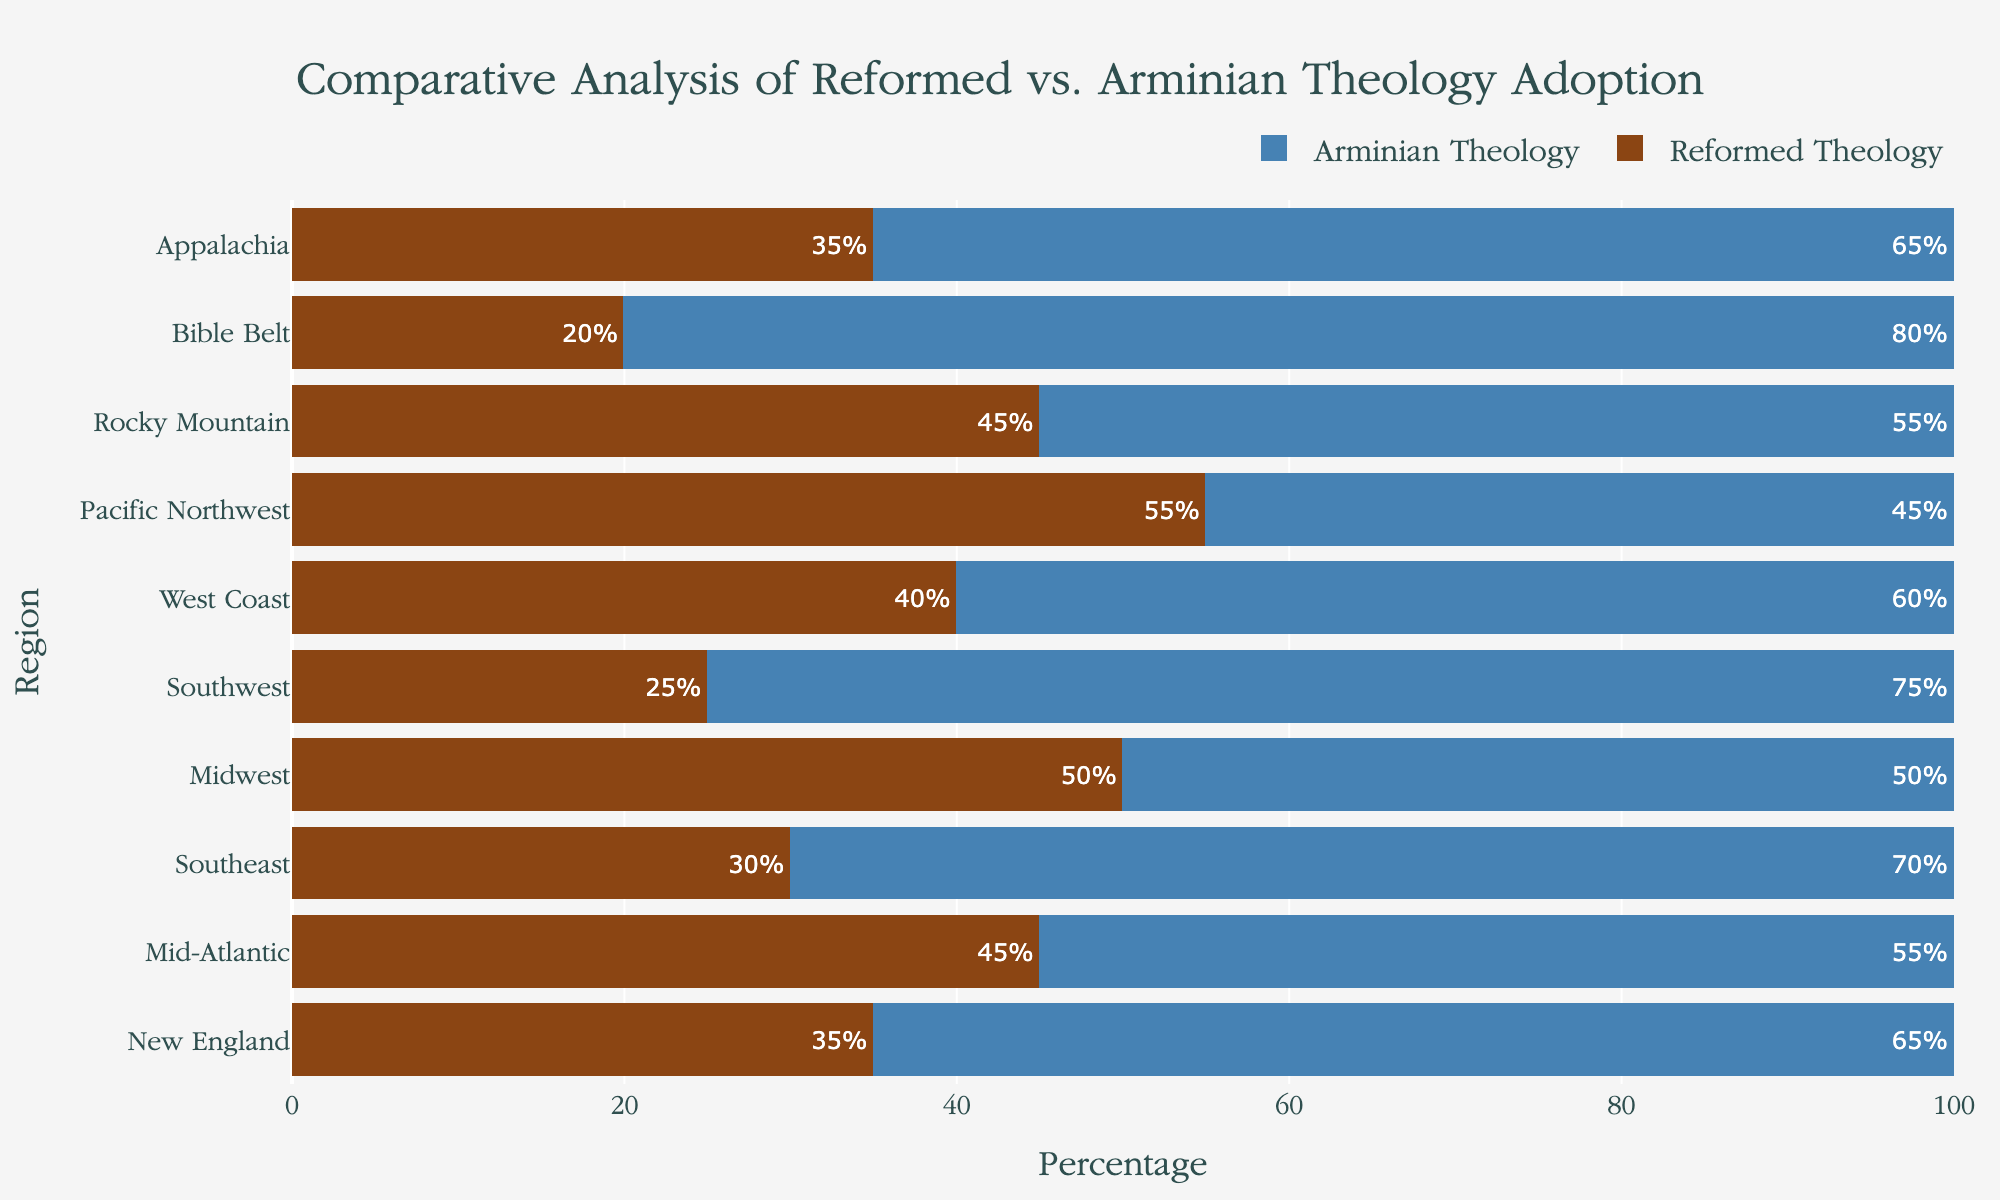How many regions have more than 50% adoption of Reformed Theology? To find this, identify which regions have a bar for Reformed Theology extending beyond the 50% mark on the x-axis. The regions with more than 50% adoption are the Midwest and the Pacific Northwest.
Answer: 2 Which region has the highest adoption rate of Arminian Theology? To determine this, look for the region with the longest blue bar for Arminian Theology. The Bible Belt has this longest bar, indicating the highest adoption rate at 80%.
Answer: Bible Belt What is the combined percentage of Reformed Theology in New England and Appalachia? For this, add the percentages shown inside the bars for Reformed Theology in New England and Appalachia. New England has 35%, and Appalachia has 35% as well. So, 35% + 35% = 70%.
Answer: 70% Which region has an equal adoption rate for both Reformed and Arminian theologies? Identify the region where the bars for both Reformed and Arminian Theologies are of equal length. The Midwest shows a bar length of 50% for both theologies.
Answer: Midwest How does the adoption rate of Reformed Theology in the Southeast compare to the Southwest? Look at the length of the bars for Reformed Theology in both regions. The Southeast has 30%, while the Southwest has 25%. 30% is greater than 25%.
Answer: Southeast is greater What is the difference in adoption rates between Arminian Theology in the Mid-Atlantic and the Midwest? Subtract the percentage of Arminian Theology in the Midwest from that in the Mid-Atlantic. The Mid-Atlantic has 55%, and the Midwest has 50%. So, 55% - 50% = 5%.
Answer: 5% In which region does Reformed Theology have exactly half of the adoption rate compared to Arminian Theology? Find the region where the percentage for Reformed Theology is exactly half of that for Arminian Theology. In the Bible Belt, Reformed Theology is 20%, and Arminian Theology is 80%, making 20% half of 80%.
Answer: Bible Belt Which regions have more than 60% adoption of Arminian Theology? Look for regions where the blue bar for Arminian Theology is above the 60% mark on the x-axis. These regions are New England, Southeast, Southwest, West Coast, and Bible Belt.
Answer: New England, Southeast, Southwest, West Coast, Bible Belt 